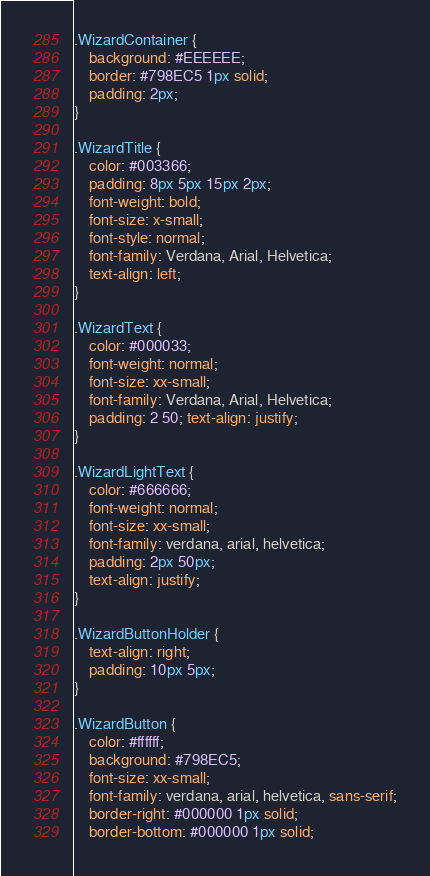Convert code to text. <code><loc_0><loc_0><loc_500><loc_500><_CSS_>.WizardContainer {
	background: #EEEEEE;
	border: #798EC5 1px solid;
	padding: 2px;
}

.WizardTitle {
	color: #003366;
	padding: 8px 5px 15px 2px;
	font-weight: bold;
	font-size: x-small;
	font-style: normal;
	font-family: Verdana, Arial, Helvetica;
	text-align: left;
}

.WizardText {
	color: #000033;
	font-weight: normal;
	font-size: xx-small;
	font-family: Verdana, Arial, Helvetica;
	padding: 2 50; text-align: justify;
}

.WizardLightText {
	color: #666666;
	font-weight: normal;
	font-size: xx-small;
	font-family: verdana, arial, helvetica;
	padding: 2px 50px;
	text-align: justify;
}

.WizardButtonHolder {
	text-align: right;
	padding: 10px 5px;
}

.WizardButton {
	color: #ffffff;
	background: #798EC5;
	font-size: xx-small;
	font-family: verdana, arial, helvetica, sans-serif;
	border-right: #000000 1px solid;
	border-bottom: #000000 1px solid;</code> 